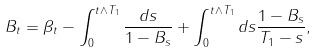Convert formula to latex. <formula><loc_0><loc_0><loc_500><loc_500>B _ { t } = \beta _ { t } - \int _ { 0 } ^ { t \wedge T _ { 1 } } \frac { d s } { 1 - B _ { s } } + \int _ { 0 } ^ { t \wedge T _ { 1 } } d s \frac { 1 - B _ { s } } { T _ { 1 } - s } ,</formula> 